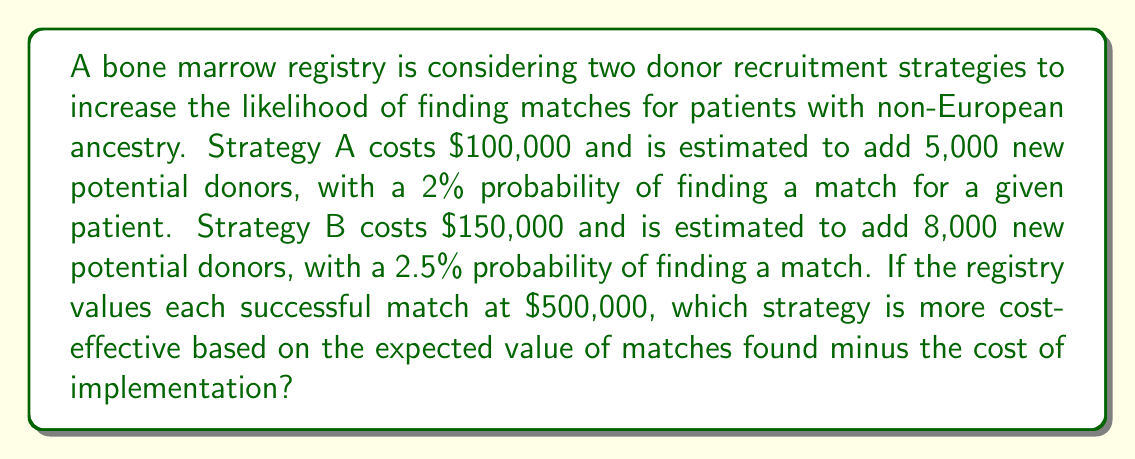What is the answer to this math problem? To determine the most cost-effective strategy, we need to calculate the expected value of each strategy and subtract the implementation cost. Let's break it down step by step:

1. Calculate the expected number of matches for each strategy:
   Strategy A: $5,000 \times 0.02 = 100$ expected matches
   Strategy B: $8,000 \times 0.025 = 200$ expected matches

2. Calculate the expected value of matches for each strategy:
   Strategy A: $100 \times \$500,000 = \$50,000,000$
   Strategy B: $200 \times \$500,000 = \$100,000,000$

3. Calculate the net expected value (expected value minus implementation cost):
   Strategy A: $\$50,000,000 - \$100,000 = \$49,900,000$
   Strategy B: $\$100,000,000 - \$150,000 = \$99,850,000$

4. Compare the net expected values:
   Strategy B has a higher net expected value ($\$99,850,000 > \$49,900,000$)

Therefore, Strategy B is more cost-effective based on the expected value of matches found minus the cost of implementation.

To express this mathematically:

Let $EV_A$ and $EV_B$ be the expected values of Strategy A and B, respectively.

$$EV_A = (5000 \times 0.02 \times \$500,000) - \$100,000 = \$49,900,000$$
$$EV_B = (8000 \times 0.025 \times \$500,000) - \$150,000 = \$99,850,000$$

Since $EV_B > EV_A$, Strategy B is more cost-effective.
Answer: Strategy B is more cost-effective, with a net expected value of $99,850,000 compared to Strategy A's $49,900,000. 